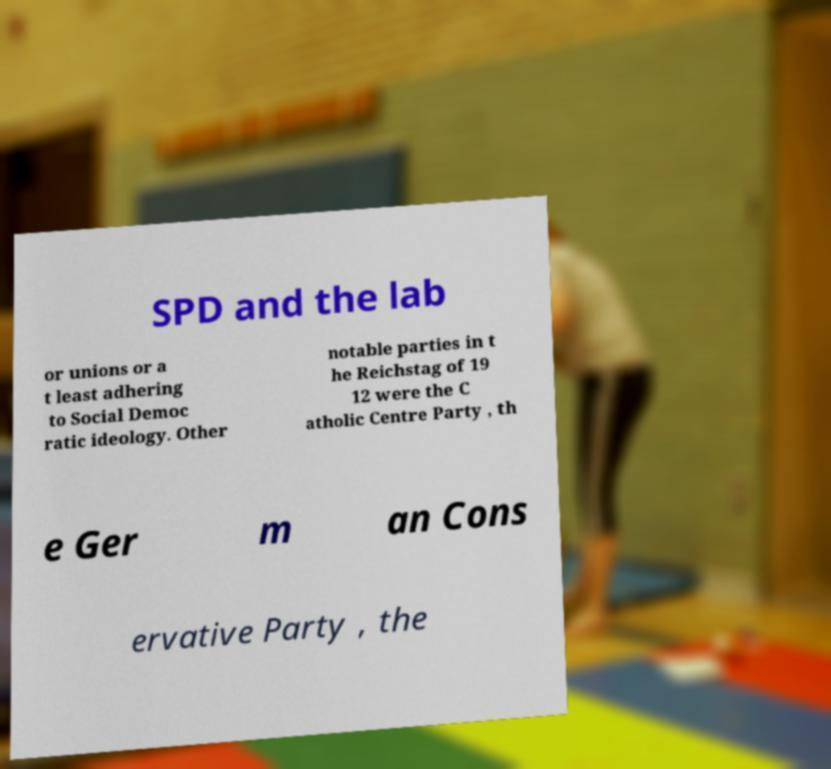Can you accurately transcribe the text from the provided image for me? SPD and the lab or unions or a t least adhering to Social Democ ratic ideology. Other notable parties in t he Reichstag of 19 12 were the C atholic Centre Party , th e Ger m an Cons ervative Party , the 